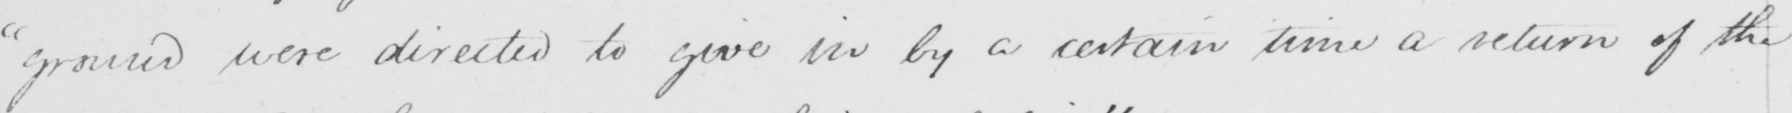Please provide the text content of this handwritten line. "ground were directed to give in by a certain time a return of the 